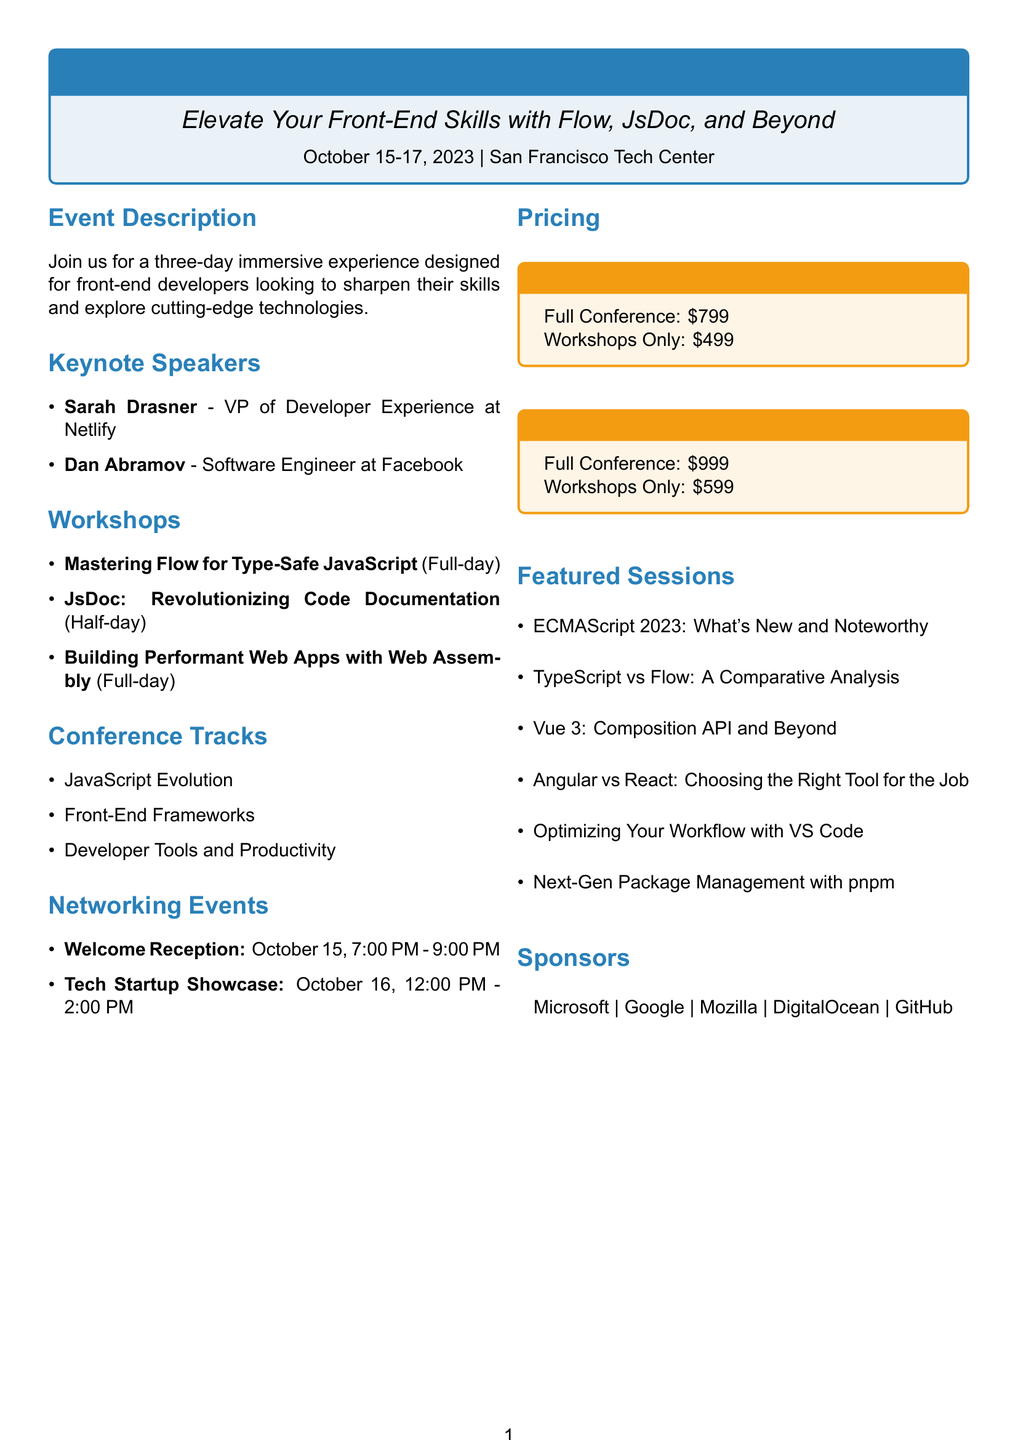what is the event name? The event name is prominently displayed at the top of the document.
Answer: FrontEdge 2023: Advancing Web Development who is the keynote speaker from Facebook? The document mentions two keynote speakers, and one of them works for Facebook.
Answer: Dan Abramov what is the date of the event? The date is clearly listed in the introductory section of the brochure.
Answer: October 15-17, 2023 how many workshops are offered? The number of workshops can be counted from the workshops section in the document.
Answer: Three what session is focused on code documentation? The conference tracks include sessions that cover various topics, including code documentation.
Answer: JsDoc: Revolutionizing Code Documentation what is the price for workshops only after the early bird deadline? The pricing section specifies the cost for workshops only in the regular pricing category.
Answer: $599 how long is the session on mastering Flow? The duration of this workshop is listed within the workshops section.
Answer: Full-day what is the location of the event? The event location is mentioned in the header section of the brochure.
Answer: San Francisco Tech Center who is the instructor for the workshop on Web Assembly? The workshops section lists the instructors for each workshop.
Answer: Lin Clark 